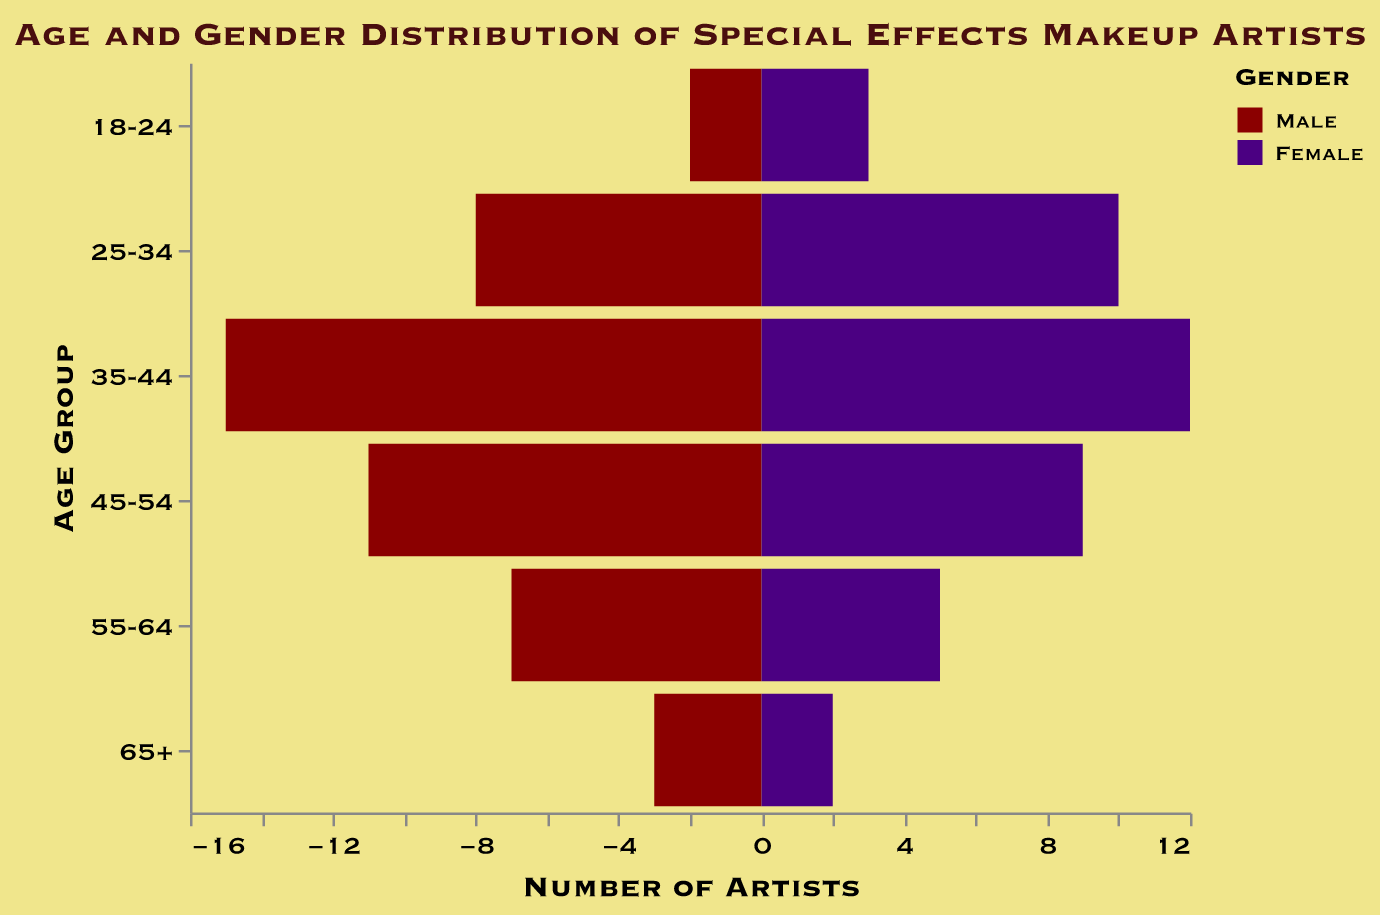How many female special effects makeup artists are in the 25-34 age group? Locate the bar for females in the 25-34 age group and read the value.
Answer: 10 Which age group has the highest number of male special effects makeup artists? Compare the height of the bars for males across all age groups and identify the age group with the tallest bar.
Answer: 35-44 What is the combined total number of special effects makeup artists in the 55-64 age group? Add the number of males and females in the 55-64 age group. (7 males + 5 females = 12)
Answer: 12 Is there a larger number of special effects makeup artists aged 18-24 or 65+? Compare the combined total (male + female) for both age groups. 18-24: 2 males + 3 females = 5; 65+: 3 males + 2 females = 5. Therefore, they are equal.
Answer: Equal What is the gender ratio in the 35-44 age group? Check the number of males and females in the 35-44 age group and express as a ratio Males:Females. (15 males : 12 females)
Answer: 15:12 Which gender has a higher representation in the 45-54 age group? Compare the number of males and females in the 45-54 age group. Males: 11, Females: 9. Males have a higher representation.
Answer: Male What percentage of the total 25-34 age group is female? Calculate the percentage: (Number of females in this group / Total number in this group) * 100. (10 females / (8 males + 10 females)) * 100 = (10 / 18) * 100 ≈ 55.56%
Answer: 55.56% How many more males than females are there in the 35-44 age group? Subtract the number of females from the number of males in the 35-44 age group. (15 males - 12 females)
Answer: 3 What is the total number of male special effects makeup artists across all age groups? Add up the number of males in each age group. (2 + 8 + 15 + 11 + 7 + 3)
Answer: 46 How does the population distribution of special effects makeup artists compare between the 25-34 and 35-44 age groups? Analyze the total numbers in each age group and gender distribution: 25-34 age group: 8 males + 10 females = 18; 35-44 age group: 15 males + 12 females = 27. 35-44 has a higher total.
Answer: 35-44 has a higher total 